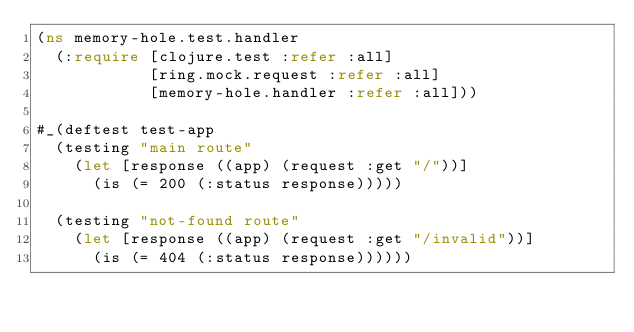Convert code to text. <code><loc_0><loc_0><loc_500><loc_500><_Clojure_>(ns memory-hole.test.handler
  (:require [clojure.test :refer :all]
            [ring.mock.request :refer :all]
            [memory-hole.handler :refer :all]))

#_(deftest test-app
  (testing "main route"
    (let [response ((app) (request :get "/"))]
      (is (= 200 (:status response)))))

  (testing "not-found route"
    (let [response ((app) (request :get "/invalid"))]
      (is (= 404 (:status response))))))
</code> 